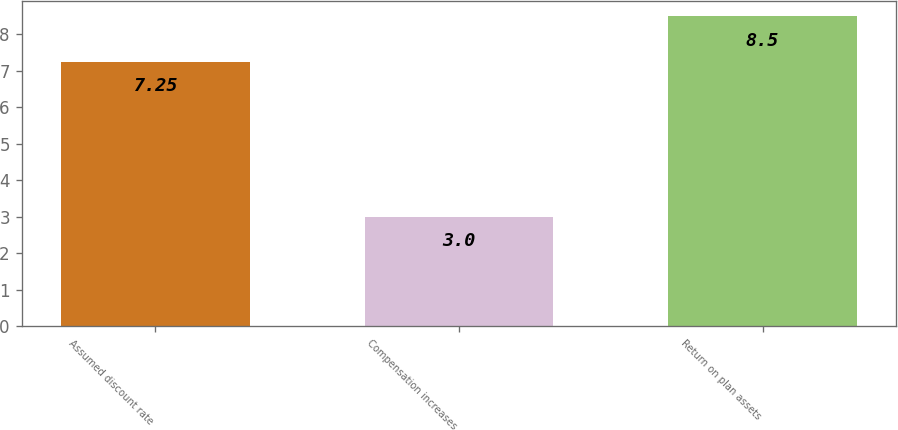<chart> <loc_0><loc_0><loc_500><loc_500><bar_chart><fcel>Assumed discount rate<fcel>Compensation increases<fcel>Return on plan assets<nl><fcel>7.25<fcel>3<fcel>8.5<nl></chart> 